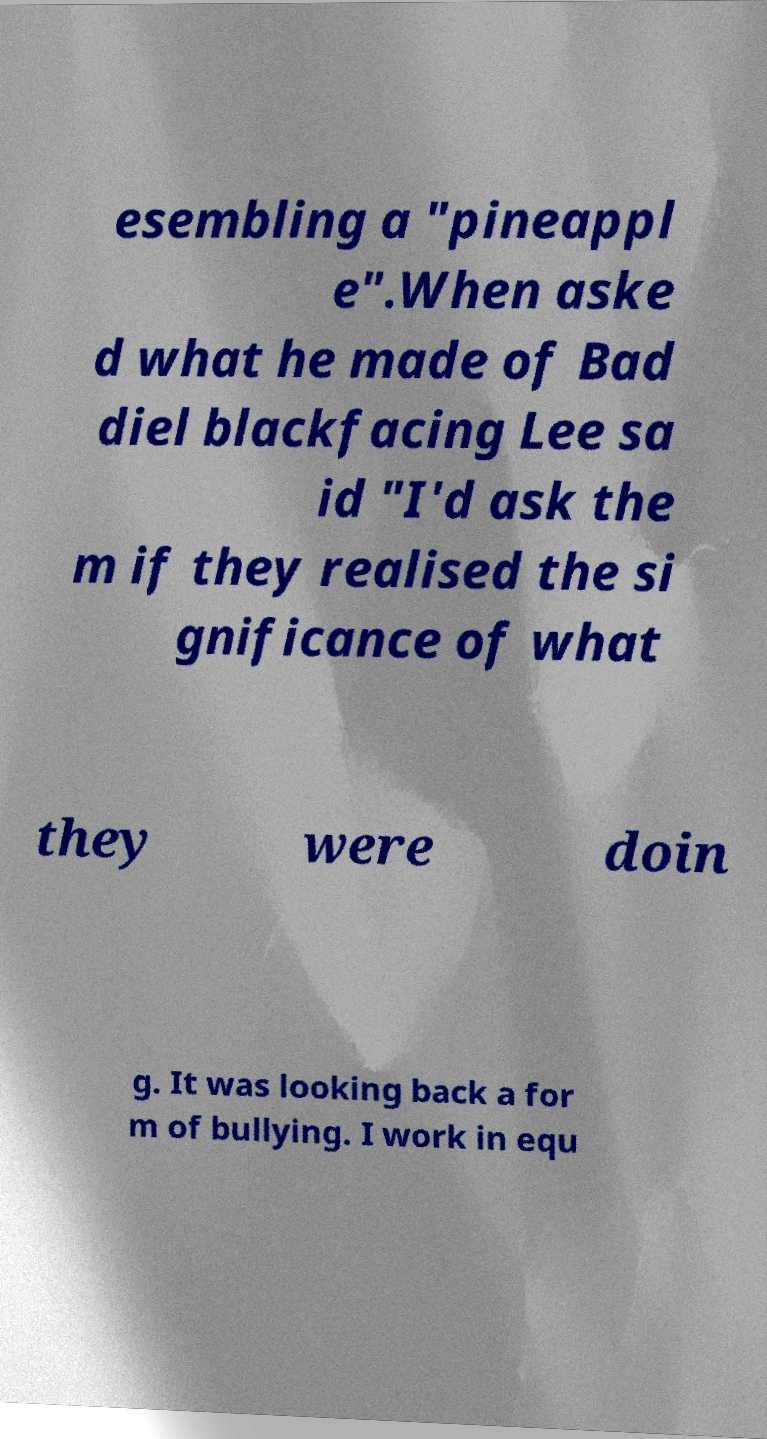There's text embedded in this image that I need extracted. Can you transcribe it verbatim? esembling a "pineappl e".When aske d what he made of Bad diel blackfacing Lee sa id "I'd ask the m if they realised the si gnificance of what they were doin g. It was looking back a for m of bullying. I work in equ 